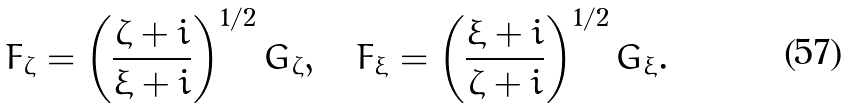Convert formula to latex. <formula><loc_0><loc_0><loc_500><loc_500>F _ { \zeta } = \left ( \frac { \zeta + i } { \xi + i } \right ) ^ { 1 / 2 } G _ { \zeta } , \quad F _ { \xi } = \left ( \frac { \xi + i } { \zeta + i } \right ) ^ { 1 / 2 } G _ { \xi } .</formula> 